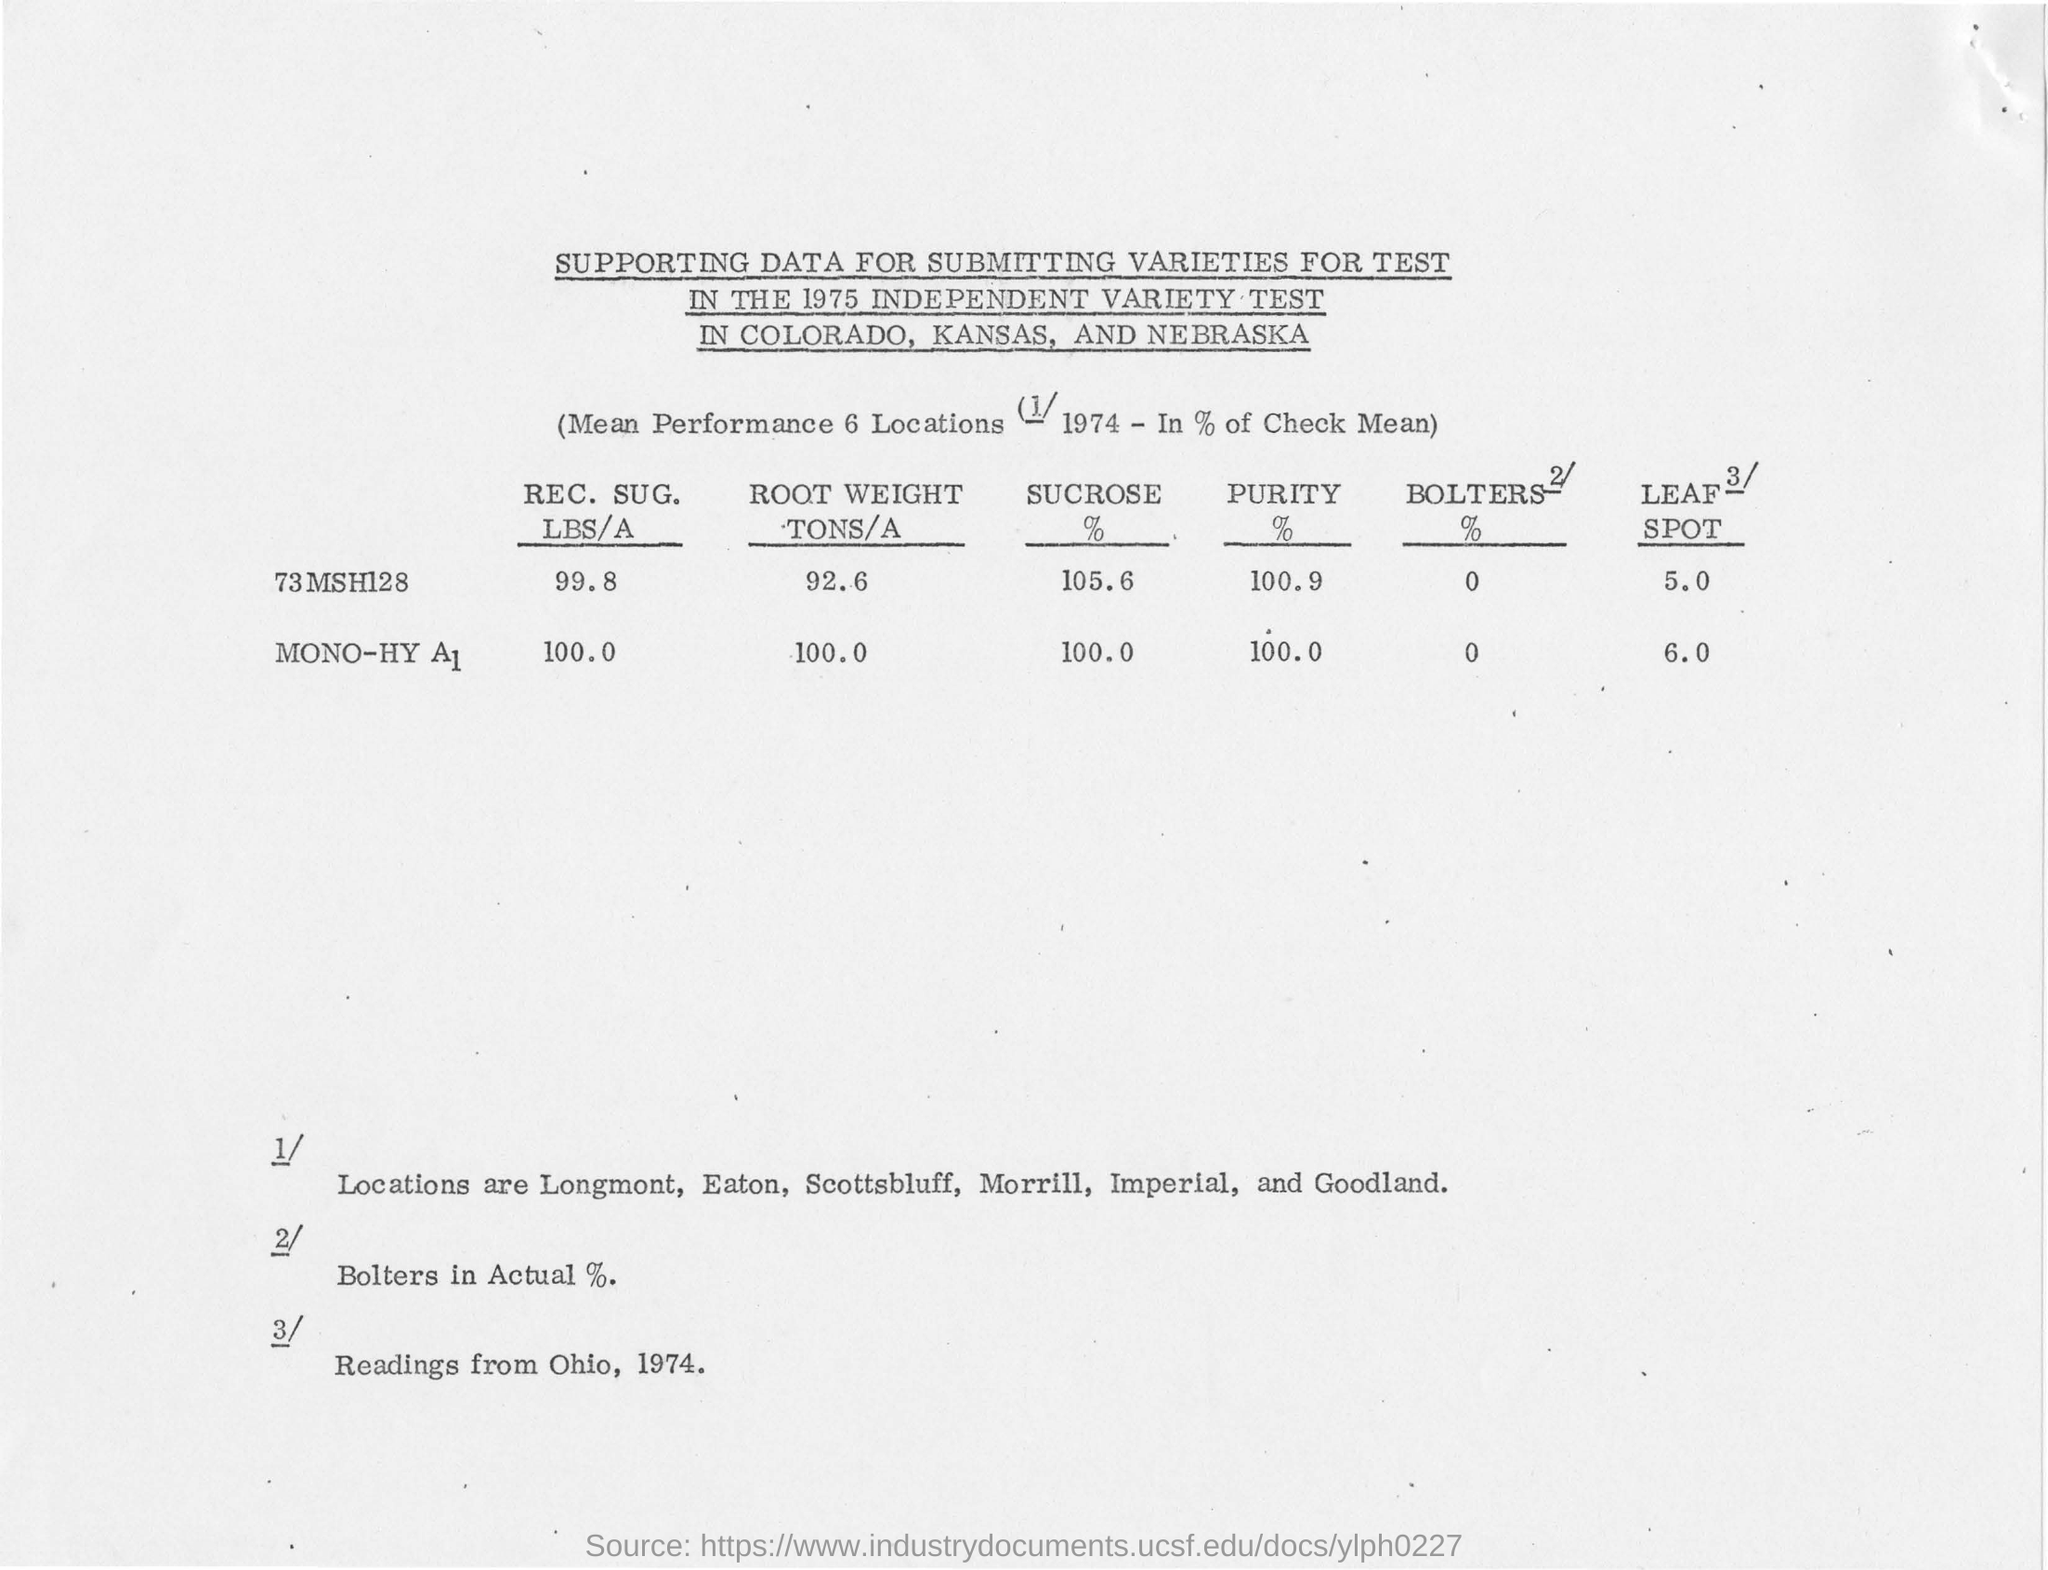Which year independent variety test is mentioned in the title of the document?
Your answer should be compact. 1975. Which is having highest SUCROSE % from the table?
Your response must be concise. 73 MSH128. How much is the ROOT WEIGHT of '73 MSH128' in TONS/A?
Make the answer very short. 92.6. 